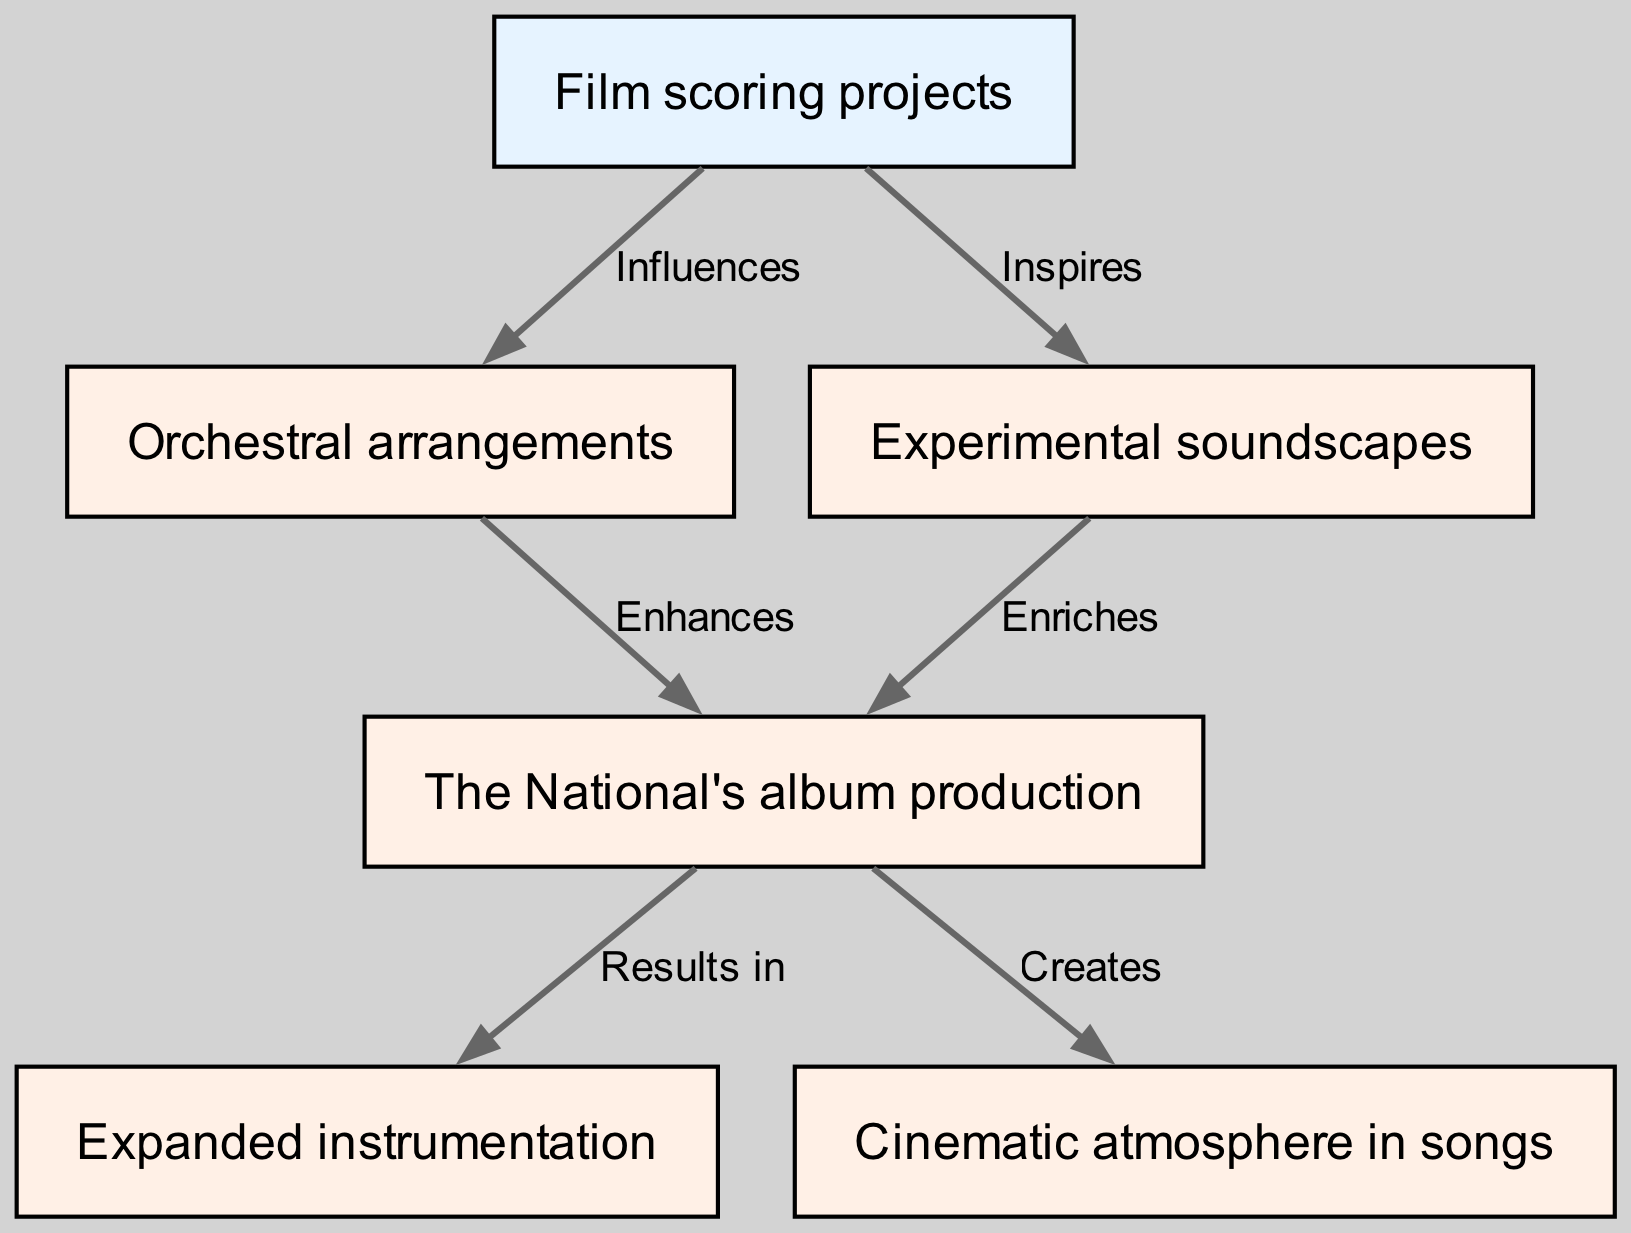What is the initial element in the diagram? The initial element is the one with no incoming edges, which is "Film scoring projects". This indicates that it serves as the starting point for the chain of influences depicted in the diagram.
Answer: Film scoring projects How many nodes are present in the diagram? By counting all the unique elements labeled in the diagram, there are six nodes: Film scoring projects, Orchestral arrangements, Experimental soundscapes, The National's album production, Expanded instrumentation, and Cinematic atmosphere in songs.
Answer: 6 Which element directly influences "Orchestral arrangements"? The edge labeled "Influences" points from "Film scoring projects" to "Orchestral arrangements", showing that the initial element has a direct effect on this node.
Answer: Film scoring projects What results from "The National's album production"? From "The National's album production", two outcomes are indicated: "Expanded instrumentation" and "Cinematic atmosphere in songs". This means both elements arise from the album production process.
Answer: Expanded instrumentation, Cinematic atmosphere in songs Which relationships enrich "The National's album production"? The relationships that enhance "The National's album production" come from both "Orchestral arrangements" and "Experimental soundscapes". The diagram indicates that both contributions serve to enrich the production.
Answer: Orchestral arrangements, Experimental soundscapes How does "Film scoring projects" relate to the element "Experimental soundscapes"? The diagram shows a directional edge labeled "Inspires" from "Film scoring projects" to "Experimental soundscapes", meaning that the film scoring projects provide inspiration for creating experimental soundscapes.
Answer: Inspires Which element is enhanced by "Orchestral arrangements"? The directed edge labeled "Enhances" leads from "Orchestral arrangements" to "The National's album production", indicating that this arrangement improves the production quality of their albums.
Answer: The National's album production What is the connection type between "Orchestral arrangements" and "The National's album production"? The connection type is described by the edge labeled "Enhances", which indicates a supportive relationship where orchestral arrangements contribute positively to the album production process.
Answer: Enhances How many edges are present in the diagram? A count of the connections (edges) shows that there are six relationships connecting the different elements in the diagram, establishing the flow of influence and enhancement among them.
Answer: 6 